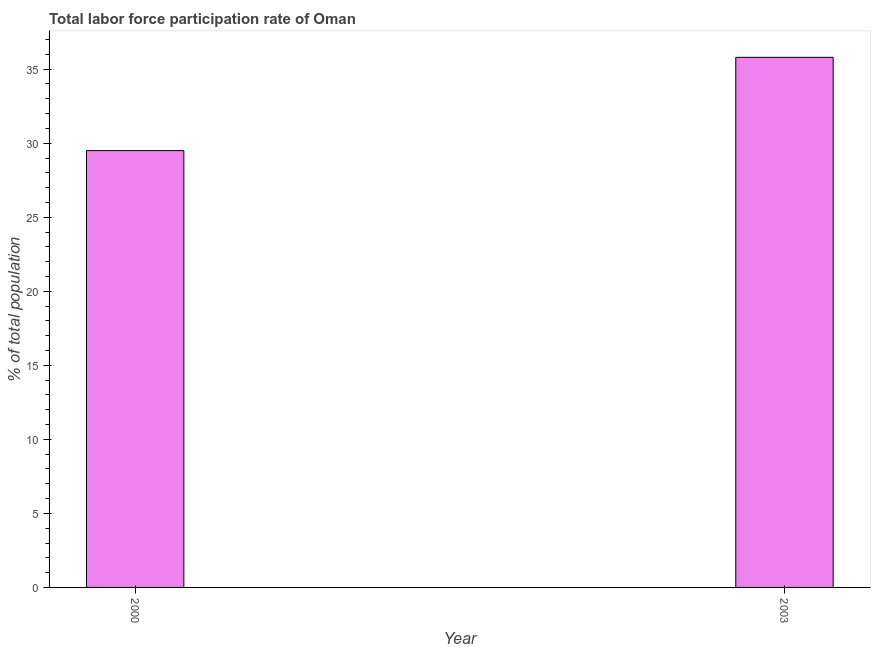Does the graph contain any zero values?
Give a very brief answer. No. What is the title of the graph?
Keep it short and to the point. Total labor force participation rate of Oman. What is the label or title of the X-axis?
Provide a short and direct response. Year. What is the label or title of the Y-axis?
Ensure brevity in your answer.  % of total population. What is the total labor force participation rate in 2000?
Ensure brevity in your answer.  29.5. Across all years, what is the maximum total labor force participation rate?
Offer a very short reply. 35.8. Across all years, what is the minimum total labor force participation rate?
Provide a short and direct response. 29.5. In which year was the total labor force participation rate maximum?
Give a very brief answer. 2003. What is the sum of the total labor force participation rate?
Your answer should be very brief. 65.3. What is the average total labor force participation rate per year?
Your answer should be very brief. 32.65. What is the median total labor force participation rate?
Your answer should be very brief. 32.65. In how many years, is the total labor force participation rate greater than 12 %?
Offer a terse response. 2. Do a majority of the years between 2003 and 2000 (inclusive) have total labor force participation rate greater than 26 %?
Keep it short and to the point. No. What is the ratio of the total labor force participation rate in 2000 to that in 2003?
Ensure brevity in your answer.  0.82. In how many years, is the total labor force participation rate greater than the average total labor force participation rate taken over all years?
Provide a succinct answer. 1. Are the values on the major ticks of Y-axis written in scientific E-notation?
Offer a very short reply. No. What is the % of total population of 2000?
Your answer should be very brief. 29.5. What is the % of total population of 2003?
Your answer should be very brief. 35.8. What is the ratio of the % of total population in 2000 to that in 2003?
Your answer should be compact. 0.82. 